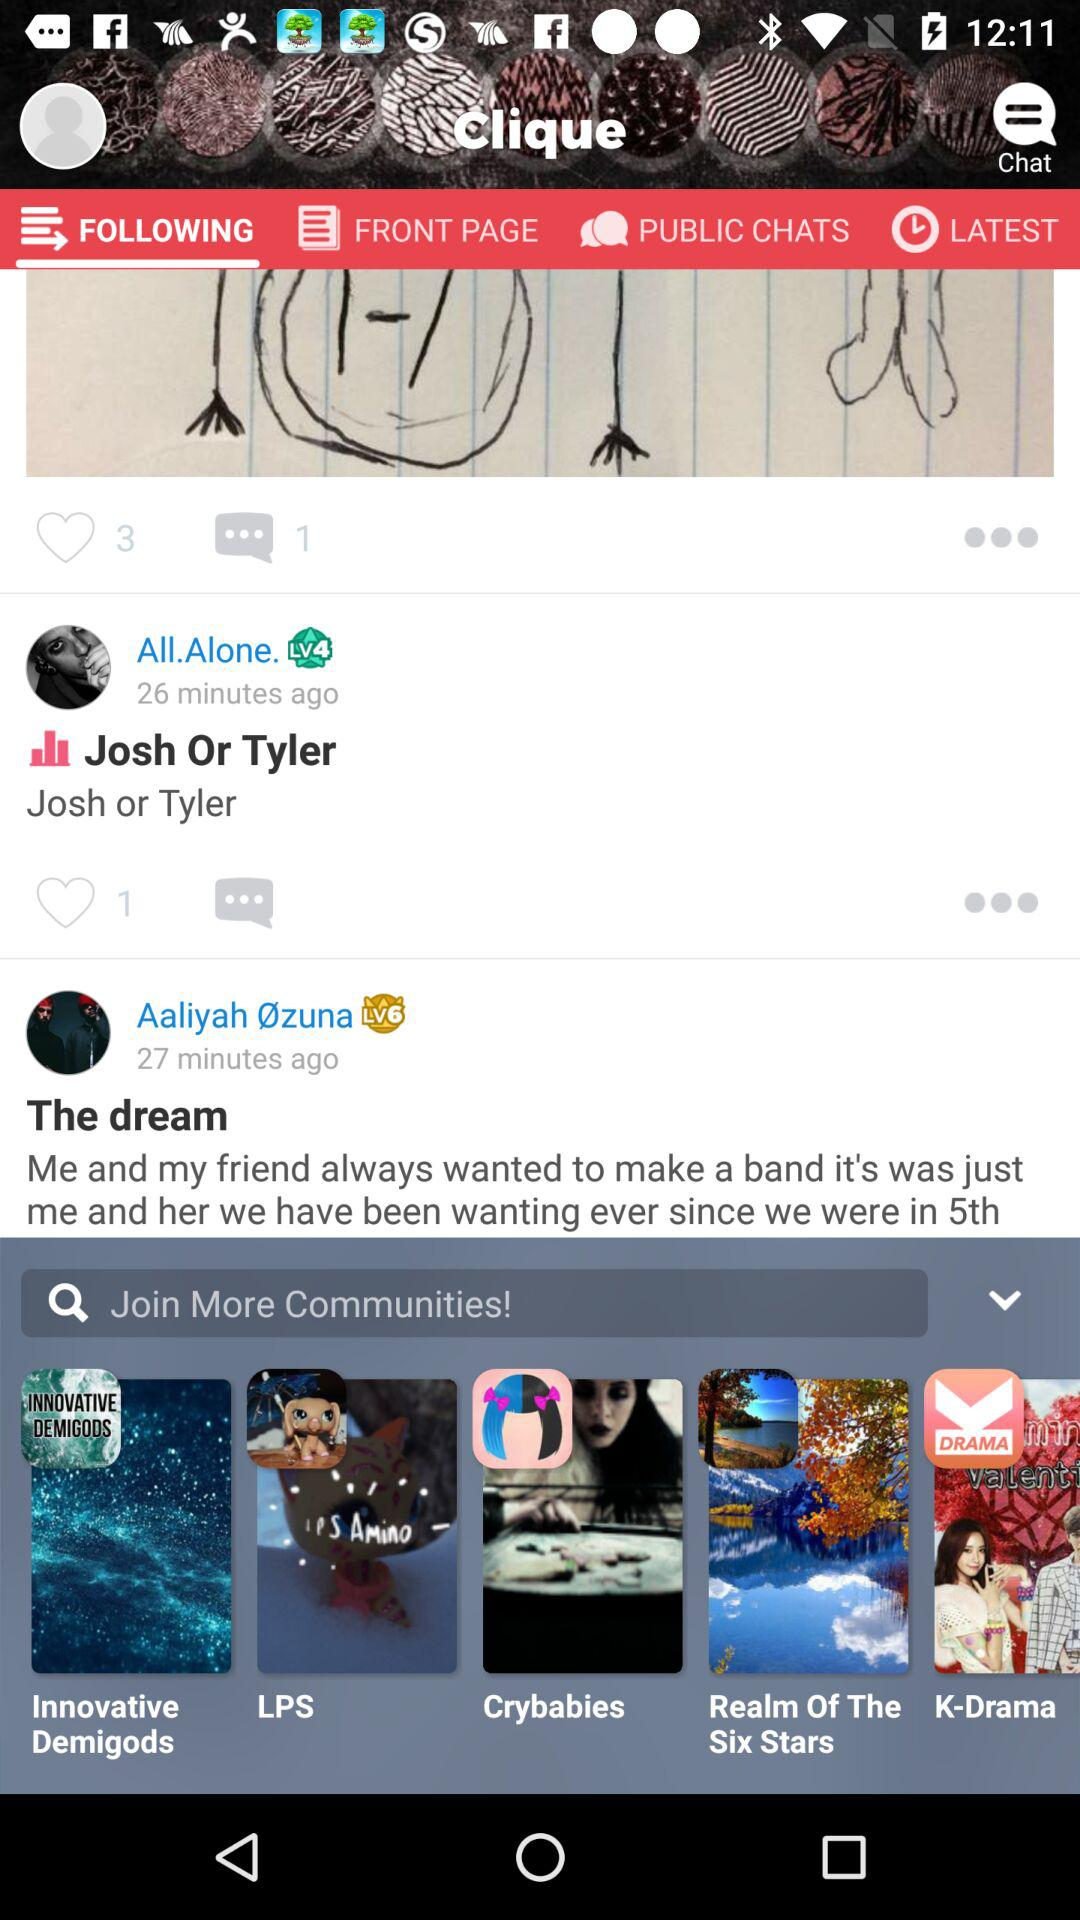How many likes are there on the post of "All.Alone."? There is 1 like on the post of "All.Alone.". 